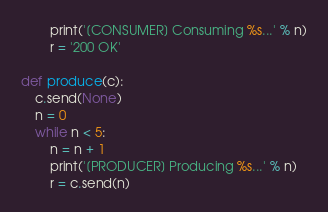Convert code to text. <code><loc_0><loc_0><loc_500><loc_500><_Python_>        print('[CONSUMER] Consuming %s...' % n)
        r = '200 OK'

def produce(c):
    c.send(None)
    n = 0
    while n < 5:
        n = n + 1
        print('[PRODUCER] Producing %s...' % n)
        r = c.send(n)</code> 